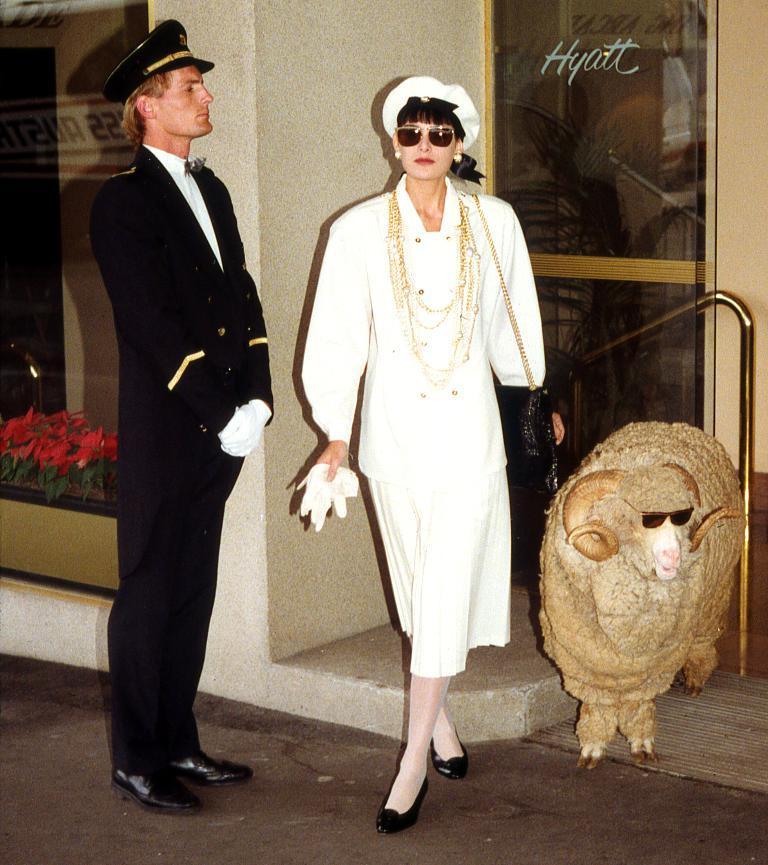Describe this image in one or two sentences. In the picture we can see a man and a woman and a sheep are standing near the wall, beside the wall we can see a glass door. 